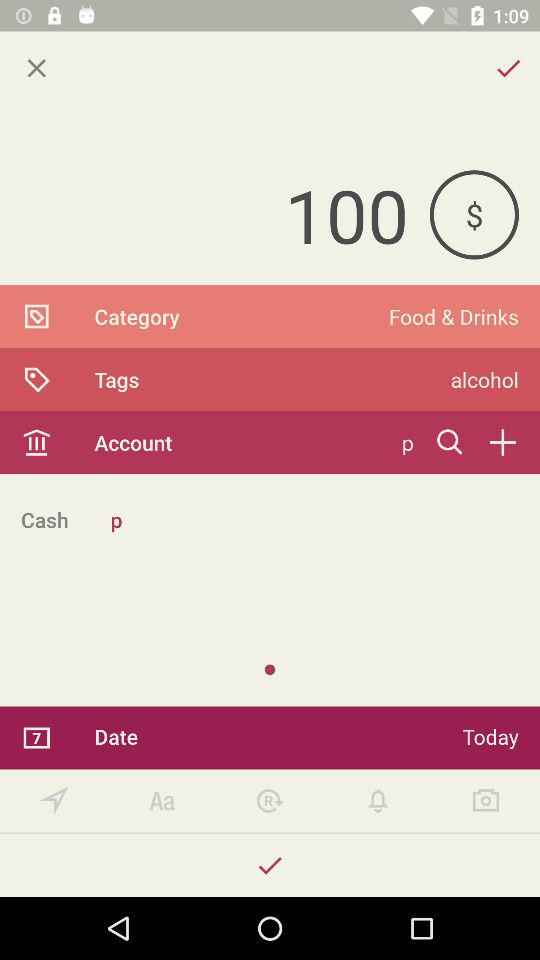What is the total amount of money spent?
Answer the question using a single word or phrase. $100 